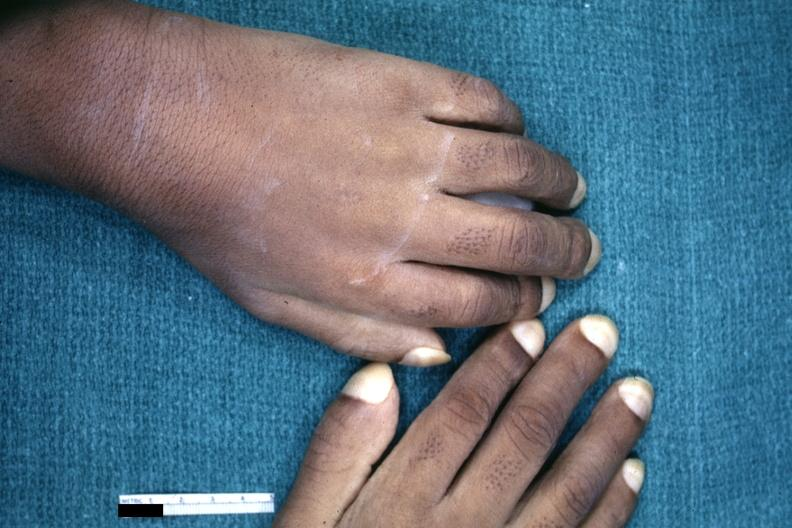re mitotic figures present?
Answer the question using a single word or phrase. No 